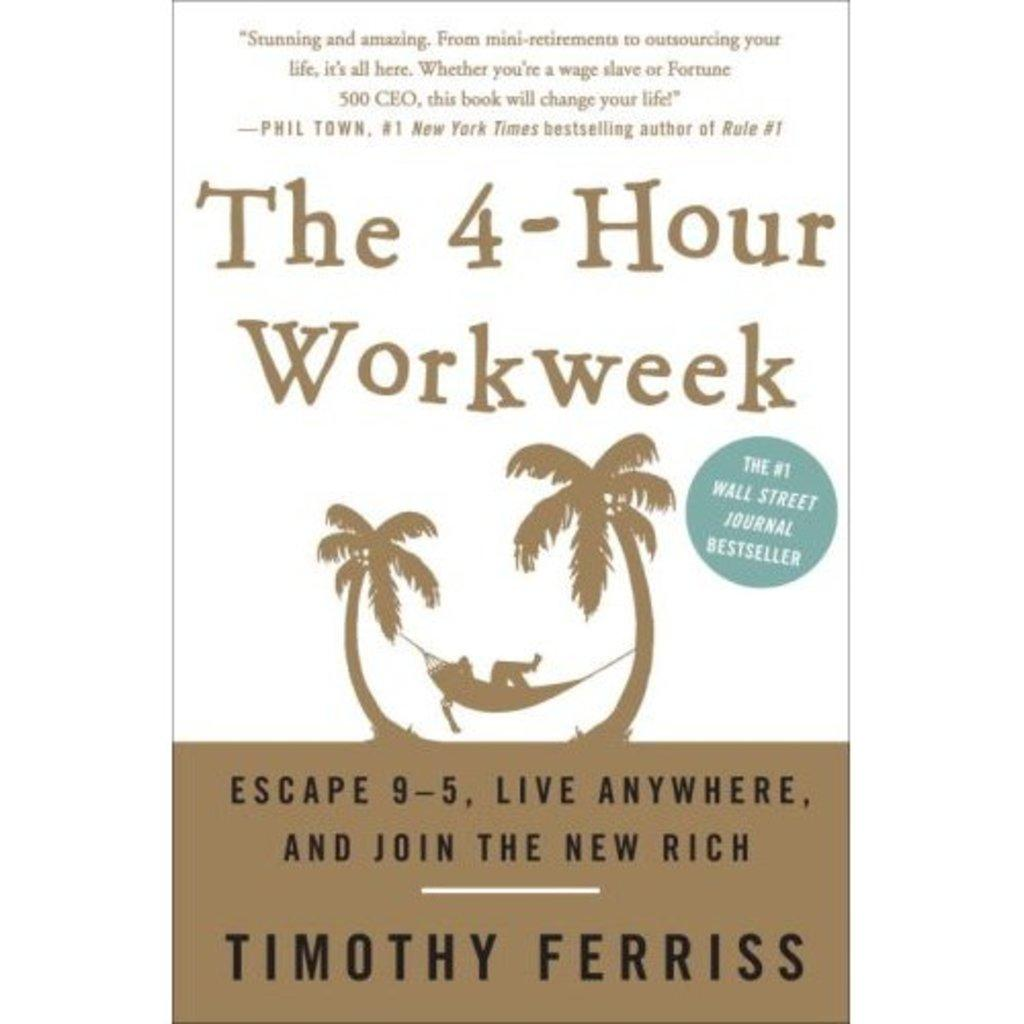What is featured on the poster in the image? The poster in the image contains both text and a picture. Can you describe the picture on the poster? Unfortunately, the provided facts do not include a description of the picture on the poster. What is the purpose of the text on the poster? The purpose of the text on the poster is not specified in the provided facts. What type of eggnog is being served in the wilderness in the image? There is no eggnog or wilderness present in the image; it features a poster with text and a picture. 